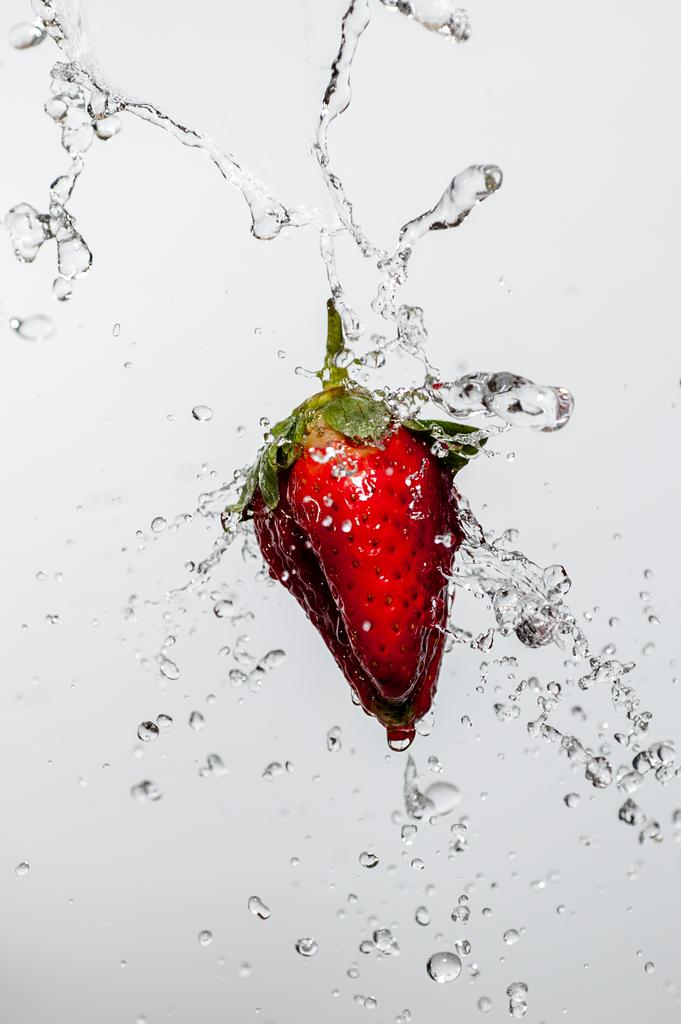What is the color of the wall in the image? The wall in the image is white. What can be seen besides the wall in the image? Water and strawberries are visible in the image. Can you see a spy in the image? There is no spy present in the image. Are the strawberries kissing each other in the image? The strawberries are not kissing each other in the image; they are simply fruits. 